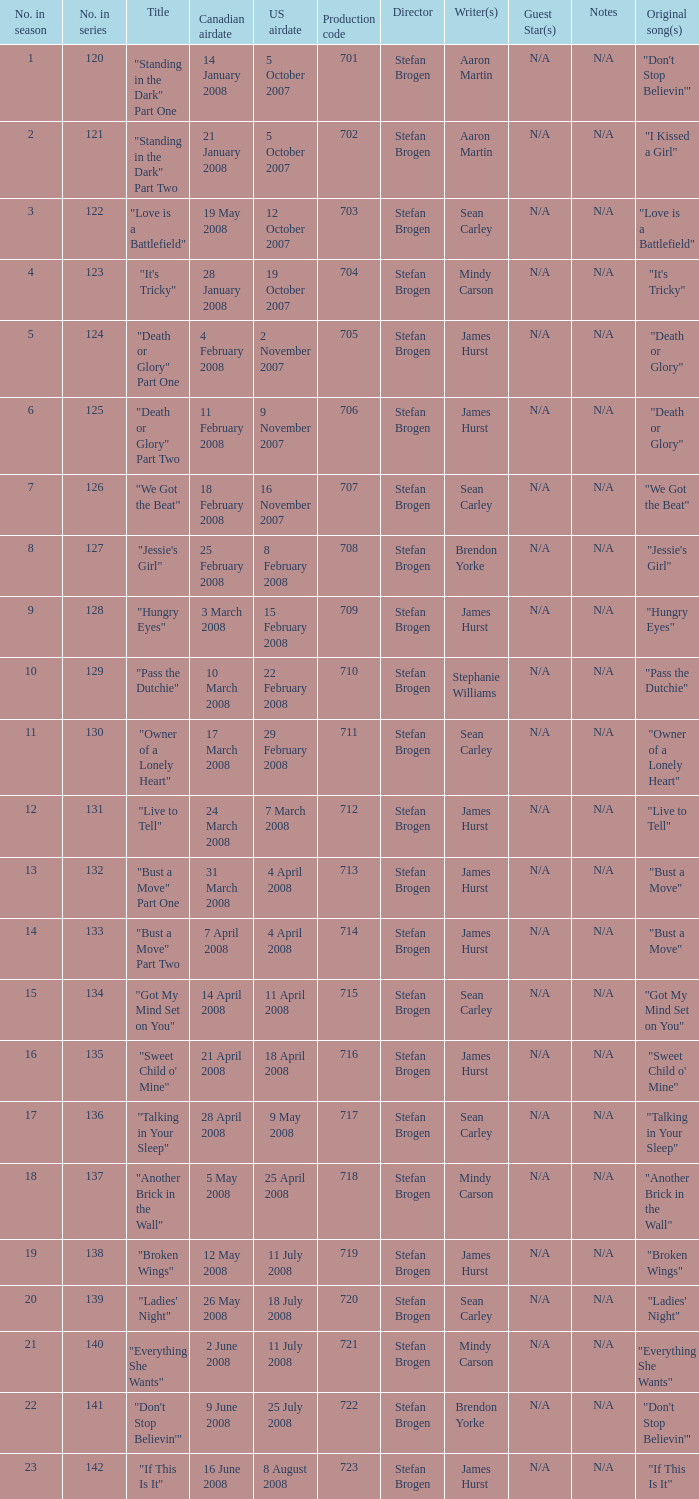Help me parse the entirety of this table. {'header': ['No. in season', 'No. in series', 'Title', 'Canadian airdate', 'US airdate', 'Production code', 'Director', 'Writer(s)', 'Guest Star(s)', 'Notes', 'Original song(s)'], 'rows': [['1', '120', '"Standing in the Dark" Part One', '14 January 2008', '5 October 2007', '701', 'Stefan Brogen', 'Aaron Martin', 'N/A', 'N/A', '"Don\'t Stop Believin\'"'], ['2', '121', '"Standing in the Dark" Part Two', '21 January 2008', '5 October 2007', '702', 'Stefan Brogen', 'Aaron Martin', 'N/A', 'N/A', '"I Kissed a Girl"'], ['3', '122', '"Love is a Battlefield"', '19 May 2008', '12 October 2007', '703', 'Stefan Brogen', 'Sean Carley', 'N/A', 'N/A', '"Love is a Battlefield"'], ['4', '123', '"It\'s Tricky"', '28 January 2008', '19 October 2007', '704', 'Stefan Brogen', 'Mindy Carson', 'N/A', 'N/A', '"It\'s Tricky"'], ['5', '124', '"Death or Glory" Part One', '4 February 2008', '2 November 2007', '705', 'Stefan Brogen', 'James Hurst', 'N/A', 'N/A', '"Death or Glory"'], ['6', '125', '"Death or Glory" Part Two', '11 February 2008', '9 November 2007', '706', 'Stefan Brogen', 'James Hurst', 'N/A', 'N/A', '"Death or Glory"'], ['7', '126', '"We Got the Beat"', '18 February 2008', '16 November 2007', '707', 'Stefan Brogen', 'Sean Carley', 'N/A', 'N/A', '"We Got the Beat"'], ['8', '127', '"Jessie\'s Girl"', '25 February 2008', '8 February 2008', '708', 'Stefan Brogen', 'Brendon Yorke', 'N/A', 'N/A', '"Jessie\'s Girl"'], ['9', '128', '"Hungry Eyes"', '3 March 2008', '15 February 2008', '709', 'Stefan Brogen', 'James Hurst', 'N/A', 'N/A', '"Hungry Eyes"'], ['10', '129', '"Pass the Dutchie"', '10 March 2008', '22 February 2008', '710', 'Stefan Brogen', 'Stephanie Williams', 'N/A', 'N/A', '"Pass the Dutchie"'], ['11', '130', '"Owner of a Lonely Heart"', '17 March 2008', '29 February 2008', '711', 'Stefan Brogen', 'Sean Carley', 'N/A', 'N/A', '"Owner of a Lonely Heart"'], ['12', '131', '"Live to Tell"', '24 March 2008', '7 March 2008', '712', 'Stefan Brogen', 'James Hurst', 'N/A', 'N/A', '"Live to Tell"'], ['13', '132', '"Bust a Move" Part One', '31 March 2008', '4 April 2008', '713', 'Stefan Brogen', 'James Hurst', 'N/A', 'N/A', '"Bust a Move"'], ['14', '133', '"Bust a Move" Part Two', '7 April 2008', '4 April 2008', '714', 'Stefan Brogen', 'James Hurst', 'N/A', 'N/A', '"Bust a Move"'], ['15', '134', '"Got My Mind Set on You"', '14 April 2008', '11 April 2008', '715', 'Stefan Brogen', 'Sean Carley', 'N/A', 'N/A', '"Got My Mind Set on You"'], ['16', '135', '"Sweet Child o\' Mine"', '21 April 2008', '18 April 2008', '716', 'Stefan Brogen', 'James Hurst', 'N/A', 'N/A', '"Sweet Child o\' Mine"'], ['17', '136', '"Talking in Your Sleep"', '28 April 2008', '9 May 2008', '717', 'Stefan Brogen', 'Sean Carley', 'N/A', 'N/A', '"Talking in Your Sleep"'], ['18', '137', '"Another Brick in the Wall"', '5 May 2008', '25 April 2008', '718', 'Stefan Brogen', 'Mindy Carson', 'N/A', 'N/A', '"Another Brick in the Wall"'], ['19', '138', '"Broken Wings"', '12 May 2008', '11 July 2008', '719', 'Stefan Brogen', 'James Hurst', 'N/A', 'N/A', '"Broken Wings"'], ['20', '139', '"Ladies\' Night"', '26 May 2008', '18 July 2008', '720', 'Stefan Brogen', 'Sean Carley', 'N/A', 'N/A', '"Ladies\' Night"'], ['21', '140', '"Everything She Wants"', '2 June 2008', '11 July 2008', '721', 'Stefan Brogen', 'Mindy Carson', 'N/A', 'N/A', '"Everything She Wants"'], ['22', '141', '"Don\'t Stop Believin\'"', '9 June 2008', '25 July 2008', '722', 'Stefan Brogen', 'Brendon Yorke', 'N/A', 'N/A', '"Don\'t Stop Believin\'"'], ['23', '142', '"If This Is It"', '16 June 2008', '8 August 2008', '723', 'Stefan Brogen', 'James Hurst', 'N/A', 'N/A', '"If This Is It"']]} The canadian airdate of 17 march 2008 had how many numbers in the season? 1.0. 